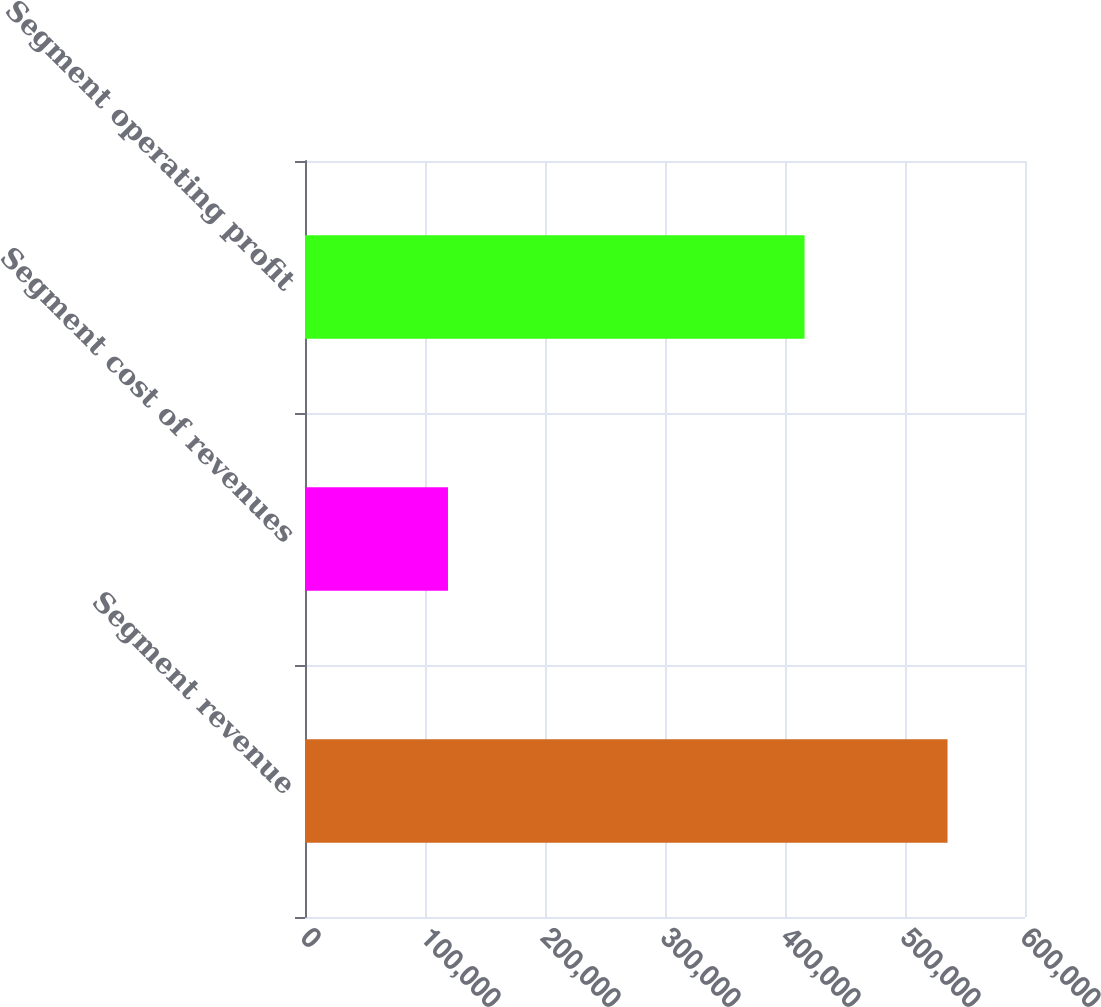Convert chart. <chart><loc_0><loc_0><loc_500><loc_500><bar_chart><fcel>Segment revenue<fcel>Segment cost of revenues<fcel>Segment operating profit<nl><fcel>535444<fcel>119141<fcel>416303<nl></chart> 